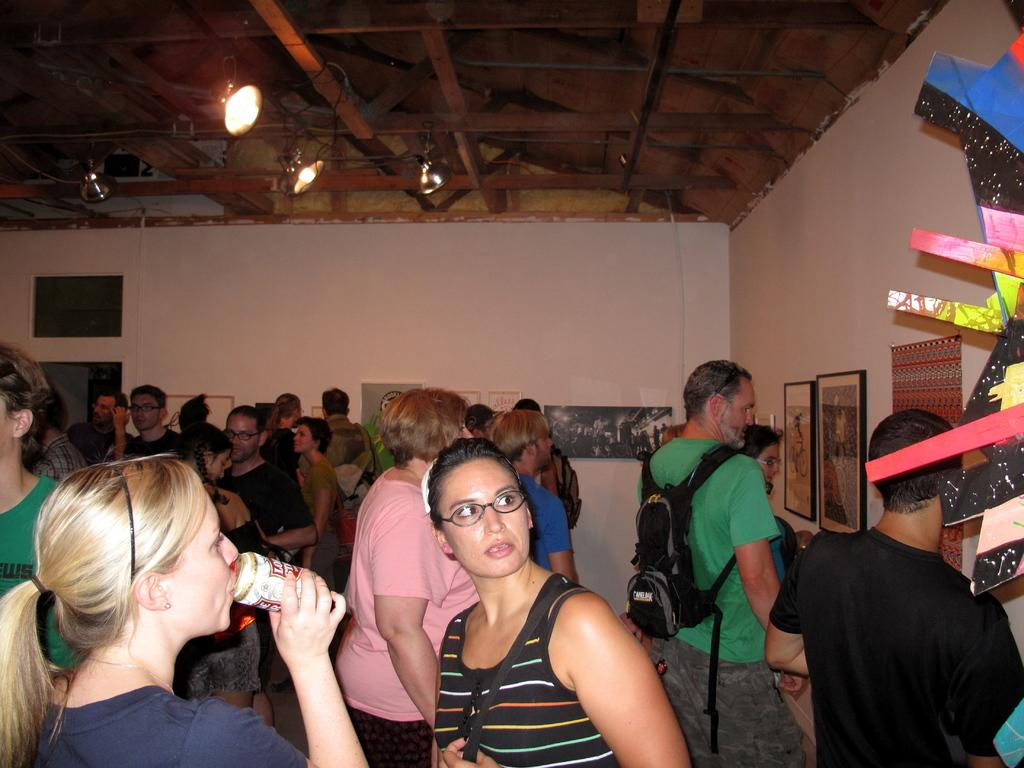How many people are in the image? There are people in the image, but the exact number is not specified. Can you describe the lady on the left side of the image? The lady on the left side of the image is standing and holding a tin. What can be seen on the right side of the image? There are boards placed on the wall on the right side of the image. What is visible at the top of the image? There are lights visible at the top of the image. Can you tell me how many teeth the lady is showing in the image? There is no indication that the lady is showing her teeth in the image. 